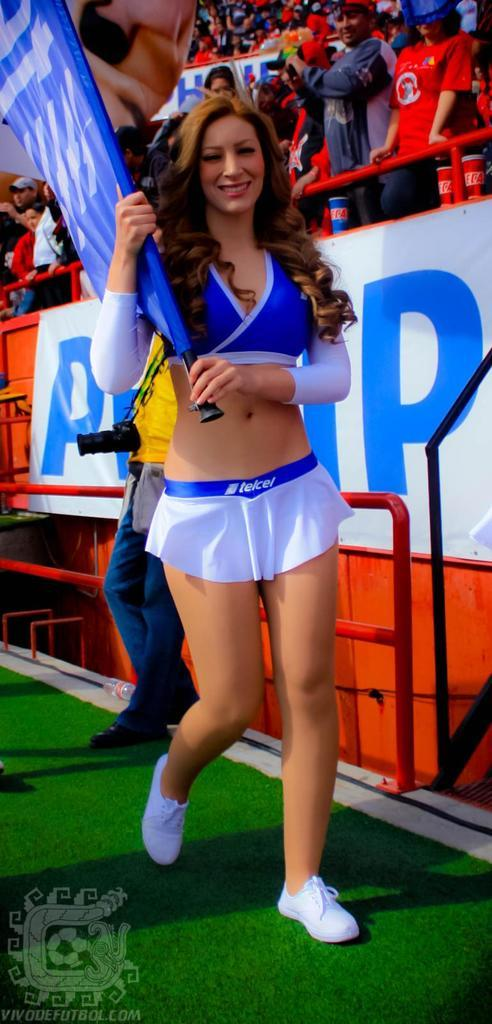<image>
Share a concise interpretation of the image provided. Cheerleader wearing a white skirt that says telcel on it. 